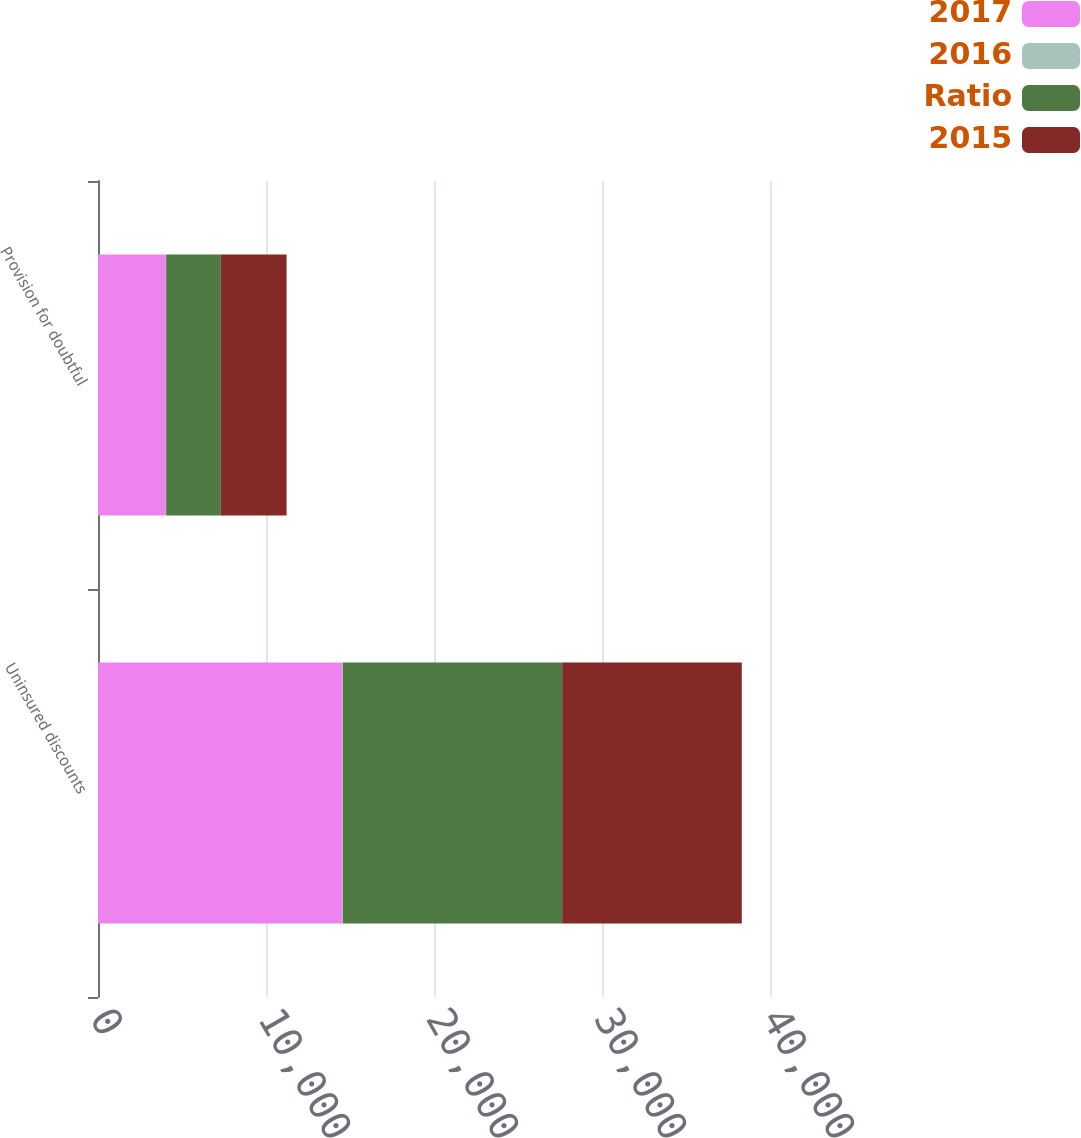<chart> <loc_0><loc_0><loc_500><loc_500><stacked_bar_chart><ecel><fcel>Uninsured discounts<fcel>Provision for doubtful<nl><fcel>2017<fcel>14520<fcel>4039<nl><fcel>2016<fcel>62<fcel>17<nl><fcel>Ratio<fcel>13047<fcel>3257<nl><fcel>2015<fcel>10692<fcel>3913<nl></chart> 